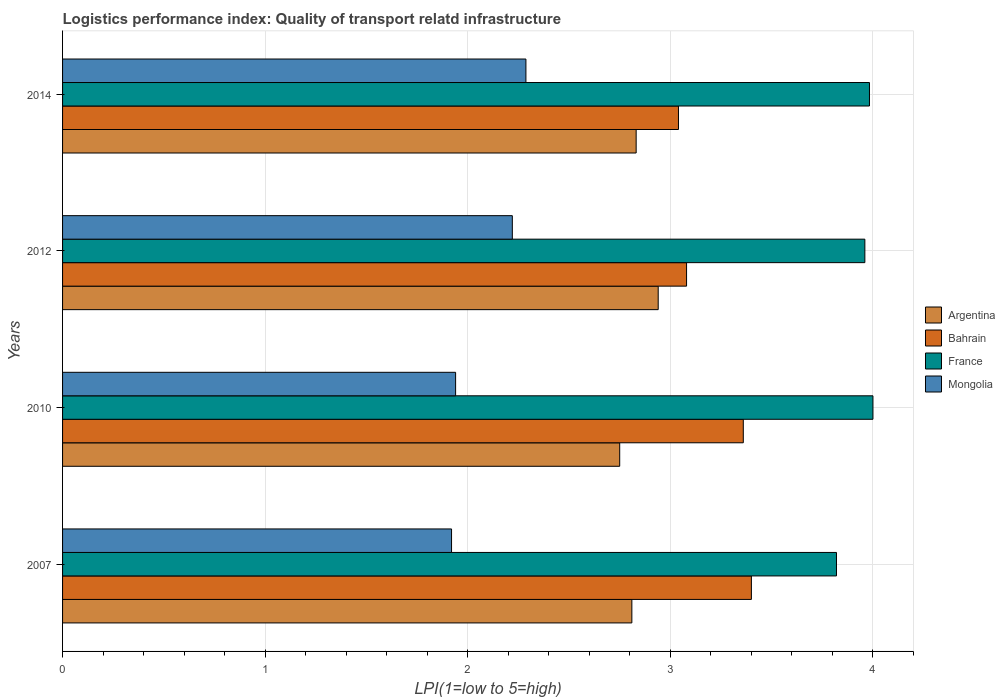How many groups of bars are there?
Make the answer very short. 4. Are the number of bars per tick equal to the number of legend labels?
Give a very brief answer. Yes. How many bars are there on the 1st tick from the top?
Provide a succinct answer. 4. In how many cases, is the number of bars for a given year not equal to the number of legend labels?
Provide a succinct answer. 0. Across all years, what is the maximum logistics performance index in Argentina?
Your answer should be very brief. 2.94. Across all years, what is the minimum logistics performance index in Bahrain?
Your response must be concise. 3.04. In which year was the logistics performance index in Mongolia maximum?
Give a very brief answer. 2014. In which year was the logistics performance index in Bahrain minimum?
Keep it short and to the point. 2014. What is the total logistics performance index in Bahrain in the graph?
Ensure brevity in your answer.  12.88. What is the difference between the logistics performance index in Mongolia in 2007 and that in 2010?
Your answer should be very brief. -0.02. What is the difference between the logistics performance index in Mongolia in 2007 and the logistics performance index in Bahrain in 2012?
Your response must be concise. -1.16. What is the average logistics performance index in Argentina per year?
Provide a short and direct response. 2.83. In the year 2014, what is the difference between the logistics performance index in Mongolia and logistics performance index in Bahrain?
Offer a very short reply. -0.75. In how many years, is the logistics performance index in Argentina greater than 2.8 ?
Give a very brief answer. 3. What is the ratio of the logistics performance index in Argentina in 2007 to that in 2010?
Offer a very short reply. 1.02. Is the logistics performance index in Argentina in 2010 less than that in 2014?
Give a very brief answer. Yes. What is the difference between the highest and the second highest logistics performance index in France?
Your answer should be very brief. 0.02. What is the difference between the highest and the lowest logistics performance index in Bahrain?
Your answer should be compact. 0.36. Is the sum of the logistics performance index in Mongolia in 2010 and 2014 greater than the maximum logistics performance index in Argentina across all years?
Ensure brevity in your answer.  Yes. Is it the case that in every year, the sum of the logistics performance index in Bahrain and logistics performance index in Mongolia is greater than the sum of logistics performance index in France and logistics performance index in Argentina?
Make the answer very short. No. What does the 3rd bar from the top in 2012 represents?
Provide a short and direct response. Bahrain. What does the 2nd bar from the bottom in 2010 represents?
Keep it short and to the point. Bahrain. Is it the case that in every year, the sum of the logistics performance index in France and logistics performance index in Bahrain is greater than the logistics performance index in Argentina?
Ensure brevity in your answer.  Yes. How many bars are there?
Your answer should be very brief. 16. Are all the bars in the graph horizontal?
Your answer should be very brief. Yes. Does the graph contain grids?
Give a very brief answer. Yes. How many legend labels are there?
Your answer should be compact. 4. How are the legend labels stacked?
Offer a very short reply. Vertical. What is the title of the graph?
Your answer should be very brief. Logistics performance index: Quality of transport relatd infrastructure. What is the label or title of the X-axis?
Offer a terse response. LPI(1=low to 5=high). What is the label or title of the Y-axis?
Your response must be concise. Years. What is the LPI(1=low to 5=high) of Argentina in 2007?
Offer a very short reply. 2.81. What is the LPI(1=low to 5=high) of Bahrain in 2007?
Your answer should be very brief. 3.4. What is the LPI(1=low to 5=high) of France in 2007?
Provide a succinct answer. 3.82. What is the LPI(1=low to 5=high) of Mongolia in 2007?
Provide a short and direct response. 1.92. What is the LPI(1=low to 5=high) of Argentina in 2010?
Offer a terse response. 2.75. What is the LPI(1=low to 5=high) of Bahrain in 2010?
Your answer should be very brief. 3.36. What is the LPI(1=low to 5=high) in France in 2010?
Give a very brief answer. 4. What is the LPI(1=low to 5=high) of Mongolia in 2010?
Your answer should be compact. 1.94. What is the LPI(1=low to 5=high) of Argentina in 2012?
Ensure brevity in your answer.  2.94. What is the LPI(1=low to 5=high) in Bahrain in 2012?
Make the answer very short. 3.08. What is the LPI(1=low to 5=high) of France in 2012?
Ensure brevity in your answer.  3.96. What is the LPI(1=low to 5=high) of Mongolia in 2012?
Your response must be concise. 2.22. What is the LPI(1=low to 5=high) of Argentina in 2014?
Ensure brevity in your answer.  2.83. What is the LPI(1=low to 5=high) of Bahrain in 2014?
Your answer should be compact. 3.04. What is the LPI(1=low to 5=high) in France in 2014?
Your answer should be compact. 3.98. What is the LPI(1=low to 5=high) in Mongolia in 2014?
Your answer should be very brief. 2.29. Across all years, what is the maximum LPI(1=low to 5=high) in Argentina?
Give a very brief answer. 2.94. Across all years, what is the maximum LPI(1=low to 5=high) in France?
Ensure brevity in your answer.  4. Across all years, what is the maximum LPI(1=low to 5=high) in Mongolia?
Ensure brevity in your answer.  2.29. Across all years, what is the minimum LPI(1=low to 5=high) in Argentina?
Ensure brevity in your answer.  2.75. Across all years, what is the minimum LPI(1=low to 5=high) of Bahrain?
Give a very brief answer. 3.04. Across all years, what is the minimum LPI(1=low to 5=high) of France?
Your answer should be very brief. 3.82. Across all years, what is the minimum LPI(1=low to 5=high) of Mongolia?
Offer a terse response. 1.92. What is the total LPI(1=low to 5=high) of Argentina in the graph?
Ensure brevity in your answer.  11.33. What is the total LPI(1=low to 5=high) in Bahrain in the graph?
Your answer should be very brief. 12.88. What is the total LPI(1=low to 5=high) in France in the graph?
Your answer should be compact. 15.76. What is the total LPI(1=low to 5=high) in Mongolia in the graph?
Provide a short and direct response. 8.37. What is the difference between the LPI(1=low to 5=high) of Argentina in 2007 and that in 2010?
Offer a very short reply. 0.06. What is the difference between the LPI(1=low to 5=high) of France in 2007 and that in 2010?
Ensure brevity in your answer.  -0.18. What is the difference between the LPI(1=low to 5=high) in Mongolia in 2007 and that in 2010?
Your response must be concise. -0.02. What is the difference between the LPI(1=low to 5=high) in Argentina in 2007 and that in 2012?
Ensure brevity in your answer.  -0.13. What is the difference between the LPI(1=low to 5=high) of Bahrain in 2007 and that in 2012?
Give a very brief answer. 0.32. What is the difference between the LPI(1=low to 5=high) of France in 2007 and that in 2012?
Give a very brief answer. -0.14. What is the difference between the LPI(1=low to 5=high) in Argentina in 2007 and that in 2014?
Keep it short and to the point. -0.02. What is the difference between the LPI(1=low to 5=high) of Bahrain in 2007 and that in 2014?
Give a very brief answer. 0.36. What is the difference between the LPI(1=low to 5=high) of France in 2007 and that in 2014?
Offer a terse response. -0.16. What is the difference between the LPI(1=low to 5=high) in Mongolia in 2007 and that in 2014?
Your answer should be very brief. -0.37. What is the difference between the LPI(1=low to 5=high) in Argentina in 2010 and that in 2012?
Offer a very short reply. -0.19. What is the difference between the LPI(1=low to 5=high) of Bahrain in 2010 and that in 2012?
Keep it short and to the point. 0.28. What is the difference between the LPI(1=low to 5=high) in France in 2010 and that in 2012?
Provide a succinct answer. 0.04. What is the difference between the LPI(1=low to 5=high) of Mongolia in 2010 and that in 2012?
Offer a terse response. -0.28. What is the difference between the LPI(1=low to 5=high) in Argentina in 2010 and that in 2014?
Ensure brevity in your answer.  -0.08. What is the difference between the LPI(1=low to 5=high) in Bahrain in 2010 and that in 2014?
Your response must be concise. 0.32. What is the difference between the LPI(1=low to 5=high) of France in 2010 and that in 2014?
Offer a very short reply. 0.02. What is the difference between the LPI(1=low to 5=high) in Mongolia in 2010 and that in 2014?
Provide a short and direct response. -0.35. What is the difference between the LPI(1=low to 5=high) in Argentina in 2012 and that in 2014?
Give a very brief answer. 0.11. What is the difference between the LPI(1=low to 5=high) in Bahrain in 2012 and that in 2014?
Provide a succinct answer. 0.04. What is the difference between the LPI(1=low to 5=high) in France in 2012 and that in 2014?
Keep it short and to the point. -0.02. What is the difference between the LPI(1=low to 5=high) of Mongolia in 2012 and that in 2014?
Ensure brevity in your answer.  -0.07. What is the difference between the LPI(1=low to 5=high) of Argentina in 2007 and the LPI(1=low to 5=high) of Bahrain in 2010?
Ensure brevity in your answer.  -0.55. What is the difference between the LPI(1=low to 5=high) of Argentina in 2007 and the LPI(1=low to 5=high) of France in 2010?
Give a very brief answer. -1.19. What is the difference between the LPI(1=low to 5=high) in Argentina in 2007 and the LPI(1=low to 5=high) in Mongolia in 2010?
Keep it short and to the point. 0.87. What is the difference between the LPI(1=low to 5=high) in Bahrain in 2007 and the LPI(1=low to 5=high) in France in 2010?
Your answer should be compact. -0.6. What is the difference between the LPI(1=low to 5=high) in Bahrain in 2007 and the LPI(1=low to 5=high) in Mongolia in 2010?
Give a very brief answer. 1.46. What is the difference between the LPI(1=low to 5=high) in France in 2007 and the LPI(1=low to 5=high) in Mongolia in 2010?
Your answer should be very brief. 1.88. What is the difference between the LPI(1=low to 5=high) in Argentina in 2007 and the LPI(1=low to 5=high) in Bahrain in 2012?
Your answer should be very brief. -0.27. What is the difference between the LPI(1=low to 5=high) in Argentina in 2007 and the LPI(1=low to 5=high) in France in 2012?
Ensure brevity in your answer.  -1.15. What is the difference between the LPI(1=low to 5=high) in Argentina in 2007 and the LPI(1=low to 5=high) in Mongolia in 2012?
Provide a succinct answer. 0.59. What is the difference between the LPI(1=low to 5=high) in Bahrain in 2007 and the LPI(1=low to 5=high) in France in 2012?
Make the answer very short. -0.56. What is the difference between the LPI(1=low to 5=high) in Bahrain in 2007 and the LPI(1=low to 5=high) in Mongolia in 2012?
Your answer should be very brief. 1.18. What is the difference between the LPI(1=low to 5=high) in Argentina in 2007 and the LPI(1=low to 5=high) in Bahrain in 2014?
Your answer should be compact. -0.23. What is the difference between the LPI(1=low to 5=high) of Argentina in 2007 and the LPI(1=low to 5=high) of France in 2014?
Your answer should be very brief. -1.17. What is the difference between the LPI(1=low to 5=high) of Argentina in 2007 and the LPI(1=low to 5=high) of Mongolia in 2014?
Keep it short and to the point. 0.52. What is the difference between the LPI(1=low to 5=high) of Bahrain in 2007 and the LPI(1=low to 5=high) of France in 2014?
Provide a short and direct response. -0.58. What is the difference between the LPI(1=low to 5=high) of Bahrain in 2007 and the LPI(1=low to 5=high) of Mongolia in 2014?
Offer a terse response. 1.11. What is the difference between the LPI(1=low to 5=high) of France in 2007 and the LPI(1=low to 5=high) of Mongolia in 2014?
Your answer should be very brief. 1.53. What is the difference between the LPI(1=low to 5=high) in Argentina in 2010 and the LPI(1=low to 5=high) in Bahrain in 2012?
Make the answer very short. -0.33. What is the difference between the LPI(1=low to 5=high) of Argentina in 2010 and the LPI(1=low to 5=high) of France in 2012?
Your answer should be compact. -1.21. What is the difference between the LPI(1=low to 5=high) of Argentina in 2010 and the LPI(1=low to 5=high) of Mongolia in 2012?
Offer a terse response. 0.53. What is the difference between the LPI(1=low to 5=high) in Bahrain in 2010 and the LPI(1=low to 5=high) in Mongolia in 2012?
Make the answer very short. 1.14. What is the difference between the LPI(1=low to 5=high) of France in 2010 and the LPI(1=low to 5=high) of Mongolia in 2012?
Make the answer very short. 1.78. What is the difference between the LPI(1=low to 5=high) in Argentina in 2010 and the LPI(1=low to 5=high) in Bahrain in 2014?
Your answer should be compact. -0.29. What is the difference between the LPI(1=low to 5=high) of Argentina in 2010 and the LPI(1=low to 5=high) of France in 2014?
Your response must be concise. -1.23. What is the difference between the LPI(1=low to 5=high) in Argentina in 2010 and the LPI(1=low to 5=high) in Mongolia in 2014?
Provide a succinct answer. 0.46. What is the difference between the LPI(1=low to 5=high) in Bahrain in 2010 and the LPI(1=low to 5=high) in France in 2014?
Keep it short and to the point. -0.62. What is the difference between the LPI(1=low to 5=high) of Bahrain in 2010 and the LPI(1=low to 5=high) of Mongolia in 2014?
Ensure brevity in your answer.  1.07. What is the difference between the LPI(1=low to 5=high) of France in 2010 and the LPI(1=low to 5=high) of Mongolia in 2014?
Provide a short and direct response. 1.71. What is the difference between the LPI(1=low to 5=high) in Argentina in 2012 and the LPI(1=low to 5=high) in Bahrain in 2014?
Your answer should be compact. -0.1. What is the difference between the LPI(1=low to 5=high) of Argentina in 2012 and the LPI(1=low to 5=high) of France in 2014?
Offer a terse response. -1.04. What is the difference between the LPI(1=low to 5=high) in Argentina in 2012 and the LPI(1=low to 5=high) in Mongolia in 2014?
Offer a very short reply. 0.65. What is the difference between the LPI(1=low to 5=high) in Bahrain in 2012 and the LPI(1=low to 5=high) in France in 2014?
Make the answer very short. -0.9. What is the difference between the LPI(1=low to 5=high) of Bahrain in 2012 and the LPI(1=low to 5=high) of Mongolia in 2014?
Provide a short and direct response. 0.79. What is the difference between the LPI(1=low to 5=high) of France in 2012 and the LPI(1=low to 5=high) of Mongolia in 2014?
Your answer should be very brief. 1.67. What is the average LPI(1=low to 5=high) of Argentina per year?
Make the answer very short. 2.83. What is the average LPI(1=low to 5=high) in Bahrain per year?
Offer a very short reply. 3.22. What is the average LPI(1=low to 5=high) in France per year?
Offer a very short reply. 3.94. What is the average LPI(1=low to 5=high) of Mongolia per year?
Keep it short and to the point. 2.09. In the year 2007, what is the difference between the LPI(1=low to 5=high) in Argentina and LPI(1=low to 5=high) in Bahrain?
Provide a succinct answer. -0.59. In the year 2007, what is the difference between the LPI(1=low to 5=high) in Argentina and LPI(1=low to 5=high) in France?
Make the answer very short. -1.01. In the year 2007, what is the difference between the LPI(1=low to 5=high) of Argentina and LPI(1=low to 5=high) of Mongolia?
Offer a very short reply. 0.89. In the year 2007, what is the difference between the LPI(1=low to 5=high) of Bahrain and LPI(1=low to 5=high) of France?
Offer a very short reply. -0.42. In the year 2007, what is the difference between the LPI(1=low to 5=high) of Bahrain and LPI(1=low to 5=high) of Mongolia?
Your answer should be compact. 1.48. In the year 2007, what is the difference between the LPI(1=low to 5=high) of France and LPI(1=low to 5=high) of Mongolia?
Give a very brief answer. 1.9. In the year 2010, what is the difference between the LPI(1=low to 5=high) of Argentina and LPI(1=low to 5=high) of Bahrain?
Give a very brief answer. -0.61. In the year 2010, what is the difference between the LPI(1=low to 5=high) of Argentina and LPI(1=low to 5=high) of France?
Your response must be concise. -1.25. In the year 2010, what is the difference between the LPI(1=low to 5=high) of Argentina and LPI(1=low to 5=high) of Mongolia?
Your answer should be compact. 0.81. In the year 2010, what is the difference between the LPI(1=low to 5=high) in Bahrain and LPI(1=low to 5=high) in France?
Your answer should be compact. -0.64. In the year 2010, what is the difference between the LPI(1=low to 5=high) in Bahrain and LPI(1=low to 5=high) in Mongolia?
Give a very brief answer. 1.42. In the year 2010, what is the difference between the LPI(1=low to 5=high) in France and LPI(1=low to 5=high) in Mongolia?
Offer a terse response. 2.06. In the year 2012, what is the difference between the LPI(1=low to 5=high) in Argentina and LPI(1=low to 5=high) in Bahrain?
Ensure brevity in your answer.  -0.14. In the year 2012, what is the difference between the LPI(1=low to 5=high) of Argentina and LPI(1=low to 5=high) of France?
Offer a very short reply. -1.02. In the year 2012, what is the difference between the LPI(1=low to 5=high) in Argentina and LPI(1=low to 5=high) in Mongolia?
Your answer should be very brief. 0.72. In the year 2012, what is the difference between the LPI(1=low to 5=high) of Bahrain and LPI(1=low to 5=high) of France?
Keep it short and to the point. -0.88. In the year 2012, what is the difference between the LPI(1=low to 5=high) of Bahrain and LPI(1=low to 5=high) of Mongolia?
Provide a short and direct response. 0.86. In the year 2012, what is the difference between the LPI(1=low to 5=high) of France and LPI(1=low to 5=high) of Mongolia?
Your response must be concise. 1.74. In the year 2014, what is the difference between the LPI(1=low to 5=high) in Argentina and LPI(1=low to 5=high) in Bahrain?
Your answer should be compact. -0.21. In the year 2014, what is the difference between the LPI(1=low to 5=high) of Argentina and LPI(1=low to 5=high) of France?
Provide a succinct answer. -1.15. In the year 2014, what is the difference between the LPI(1=low to 5=high) in Argentina and LPI(1=low to 5=high) in Mongolia?
Offer a terse response. 0.54. In the year 2014, what is the difference between the LPI(1=low to 5=high) in Bahrain and LPI(1=low to 5=high) in France?
Ensure brevity in your answer.  -0.94. In the year 2014, what is the difference between the LPI(1=low to 5=high) of Bahrain and LPI(1=low to 5=high) of Mongolia?
Your answer should be compact. 0.75. In the year 2014, what is the difference between the LPI(1=low to 5=high) in France and LPI(1=low to 5=high) in Mongolia?
Offer a very short reply. 1.7. What is the ratio of the LPI(1=low to 5=high) in Argentina in 2007 to that in 2010?
Provide a short and direct response. 1.02. What is the ratio of the LPI(1=low to 5=high) of Bahrain in 2007 to that in 2010?
Provide a short and direct response. 1.01. What is the ratio of the LPI(1=low to 5=high) of France in 2007 to that in 2010?
Make the answer very short. 0.95. What is the ratio of the LPI(1=low to 5=high) in Argentina in 2007 to that in 2012?
Provide a succinct answer. 0.96. What is the ratio of the LPI(1=low to 5=high) in Bahrain in 2007 to that in 2012?
Provide a short and direct response. 1.1. What is the ratio of the LPI(1=low to 5=high) of France in 2007 to that in 2012?
Your response must be concise. 0.96. What is the ratio of the LPI(1=low to 5=high) of Mongolia in 2007 to that in 2012?
Give a very brief answer. 0.86. What is the ratio of the LPI(1=low to 5=high) of Argentina in 2007 to that in 2014?
Keep it short and to the point. 0.99. What is the ratio of the LPI(1=low to 5=high) in Bahrain in 2007 to that in 2014?
Offer a terse response. 1.12. What is the ratio of the LPI(1=low to 5=high) in France in 2007 to that in 2014?
Provide a short and direct response. 0.96. What is the ratio of the LPI(1=low to 5=high) of Mongolia in 2007 to that in 2014?
Give a very brief answer. 0.84. What is the ratio of the LPI(1=low to 5=high) of Argentina in 2010 to that in 2012?
Offer a terse response. 0.94. What is the ratio of the LPI(1=low to 5=high) in France in 2010 to that in 2012?
Make the answer very short. 1.01. What is the ratio of the LPI(1=low to 5=high) in Mongolia in 2010 to that in 2012?
Provide a short and direct response. 0.87. What is the ratio of the LPI(1=low to 5=high) in Argentina in 2010 to that in 2014?
Make the answer very short. 0.97. What is the ratio of the LPI(1=low to 5=high) of Bahrain in 2010 to that in 2014?
Give a very brief answer. 1.11. What is the ratio of the LPI(1=low to 5=high) of Mongolia in 2010 to that in 2014?
Provide a short and direct response. 0.85. What is the ratio of the LPI(1=low to 5=high) in Argentina in 2012 to that in 2014?
Provide a succinct answer. 1.04. What is the ratio of the LPI(1=low to 5=high) of Bahrain in 2012 to that in 2014?
Give a very brief answer. 1.01. What is the ratio of the LPI(1=low to 5=high) of France in 2012 to that in 2014?
Offer a very short reply. 0.99. What is the ratio of the LPI(1=low to 5=high) of Mongolia in 2012 to that in 2014?
Your response must be concise. 0.97. What is the difference between the highest and the second highest LPI(1=low to 5=high) in Argentina?
Ensure brevity in your answer.  0.11. What is the difference between the highest and the second highest LPI(1=low to 5=high) in Bahrain?
Your answer should be very brief. 0.04. What is the difference between the highest and the second highest LPI(1=low to 5=high) of France?
Your answer should be compact. 0.02. What is the difference between the highest and the second highest LPI(1=low to 5=high) in Mongolia?
Keep it short and to the point. 0.07. What is the difference between the highest and the lowest LPI(1=low to 5=high) of Argentina?
Give a very brief answer. 0.19. What is the difference between the highest and the lowest LPI(1=low to 5=high) in Bahrain?
Ensure brevity in your answer.  0.36. What is the difference between the highest and the lowest LPI(1=low to 5=high) of France?
Keep it short and to the point. 0.18. What is the difference between the highest and the lowest LPI(1=low to 5=high) in Mongolia?
Give a very brief answer. 0.37. 